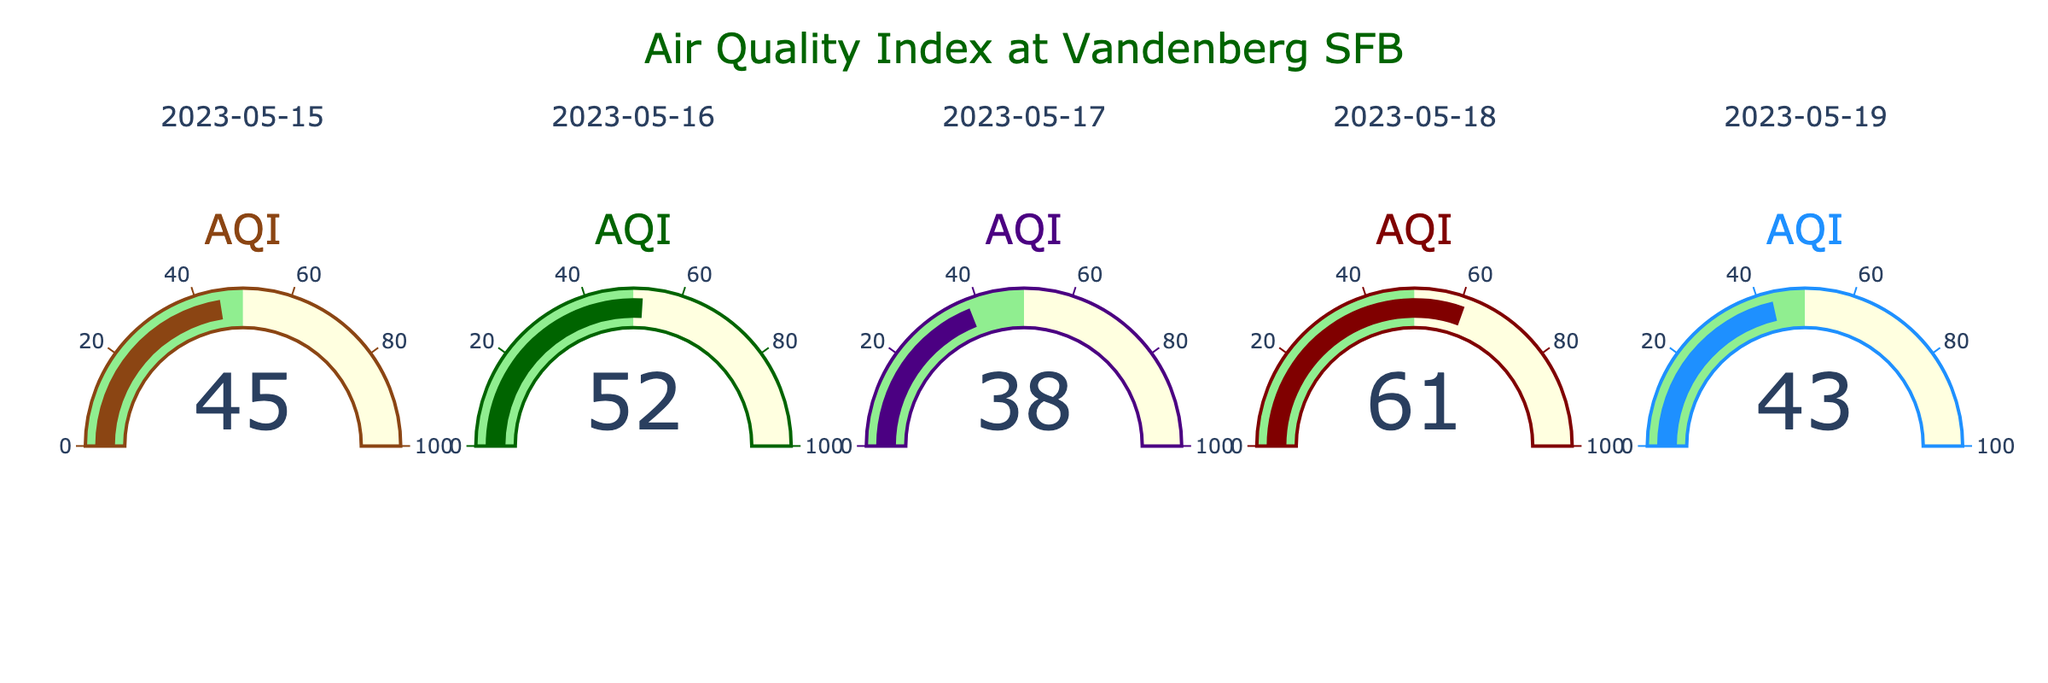How many distinct dates are represented in the figure? The figure displays the Air Quality Index (AQI) for different dates. The title of each subplot corresponds to a unique date. By counting these titles, you can determine the number of distinct dates.
Answer: 5 What is the highest AQI value recorded in the figure? To identify the highest AQI value, observe all the gauge charts and look for the plot with the highest indicated number.
Answer: 61 Which date has the lowest AQI? Compare the AQI values across all gauge charts. Identify the date with the smallest indicated number.
Answer: 2023-05-17 What is the average AQI over the provided dates? The AQIs are given as: 45, 52, 38, 61, and 43. To find the average, add these values together and divide by the number of dates: (45 + 52 + 38 + 61 + 43) / 5 = 239 / 5.
Answer: 47.8 How does the AQI on 2023-05-19 compare to the AQI on 2023-05-15? Identify the AQI values for both dates from their respective gauge charts: 43 for 2023-05-19 and 45 for 2023-05-15. Compare to see which one is higher or if they are equal.
Answer: 2023-05-15 has a higher AQI Which color is used to represent the gauge for May 17, 2023? Refer to the custom colors code and match it with the sequence in the visual representation. The gauge for May 17, 2023, corresponds to the third subplot.
Answer: Indigo (or purple) What's the median AQI value of the five dates represented? List the AQI values in ascending order: 38, 43, 45, 52, 61. The median is the middle number of this ordered list.
Answer: 45 Is there a visual indication of a safe AQI range in the gauge charts? Examine the gauge charts to see if there's a visual element indicating safety. Notice the green section representing the range from 0 to 50.
Answer: Yes, green indicates a safe AQI range (0-50) On which date did the AQI fall into the yellow range? The yellow range in the gauge charts is from 50 to 100. Identify the date or dates where AQI values fall within this range.
Answer: 2023-05-16 and 2023-05-18 What is the total sum of AQIs over the five days? Add all the AQI values together: 45, 52, 38, 61, and 43. Calculate the sum: 45 + 52 + 38 + 61 + 43 = 239.
Answer: 239 